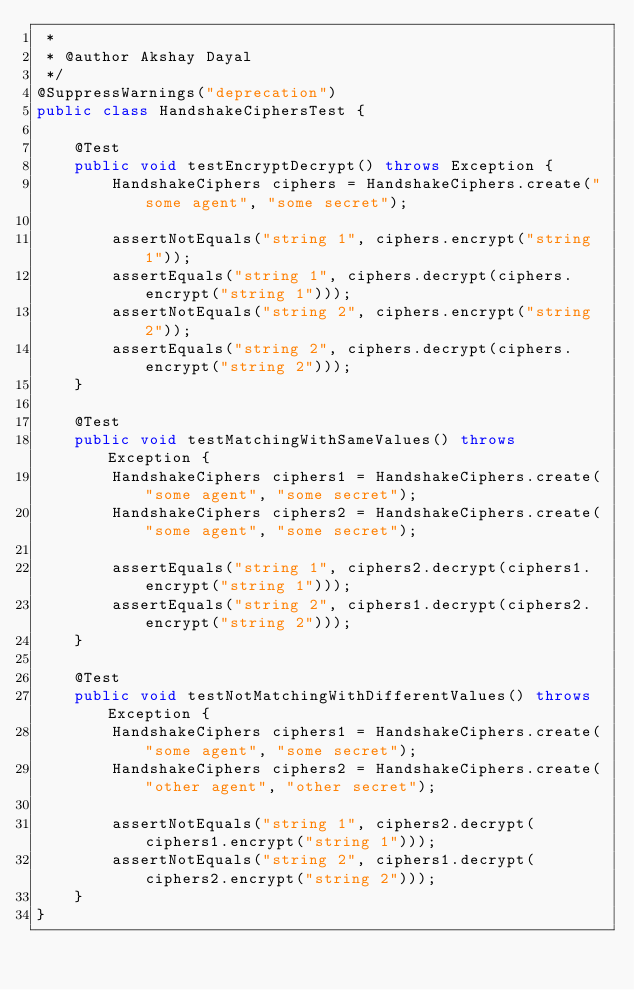<code> <loc_0><loc_0><loc_500><loc_500><_Java_> *
 * @author Akshay Dayal
 */
@SuppressWarnings("deprecation")
public class HandshakeCiphersTest {

    @Test
    public void testEncryptDecrypt() throws Exception {
        HandshakeCiphers ciphers = HandshakeCiphers.create("some agent", "some secret");

        assertNotEquals("string 1", ciphers.encrypt("string 1"));
        assertEquals("string 1", ciphers.decrypt(ciphers.encrypt("string 1")));
        assertNotEquals("string 2", ciphers.encrypt("string 2"));
        assertEquals("string 2", ciphers.decrypt(ciphers.encrypt("string 2")));
    }

    @Test
    public void testMatchingWithSameValues() throws Exception {
        HandshakeCiphers ciphers1 = HandshakeCiphers.create("some agent", "some secret");
        HandshakeCiphers ciphers2 = HandshakeCiphers.create("some agent", "some secret");

        assertEquals("string 1", ciphers2.decrypt(ciphers1.encrypt("string 1")));
        assertEquals("string 2", ciphers1.decrypt(ciphers2.encrypt("string 2")));
    }

    @Test
    public void testNotMatchingWithDifferentValues() throws Exception {
        HandshakeCiphers ciphers1 = HandshakeCiphers.create("some agent", "some secret");
        HandshakeCiphers ciphers2 = HandshakeCiphers.create("other agent", "other secret");

        assertNotEquals("string 1", ciphers2.decrypt(ciphers1.encrypt("string 1")));
        assertNotEquals("string 2", ciphers1.decrypt(ciphers2.encrypt("string 2")));
    }
}
</code> 